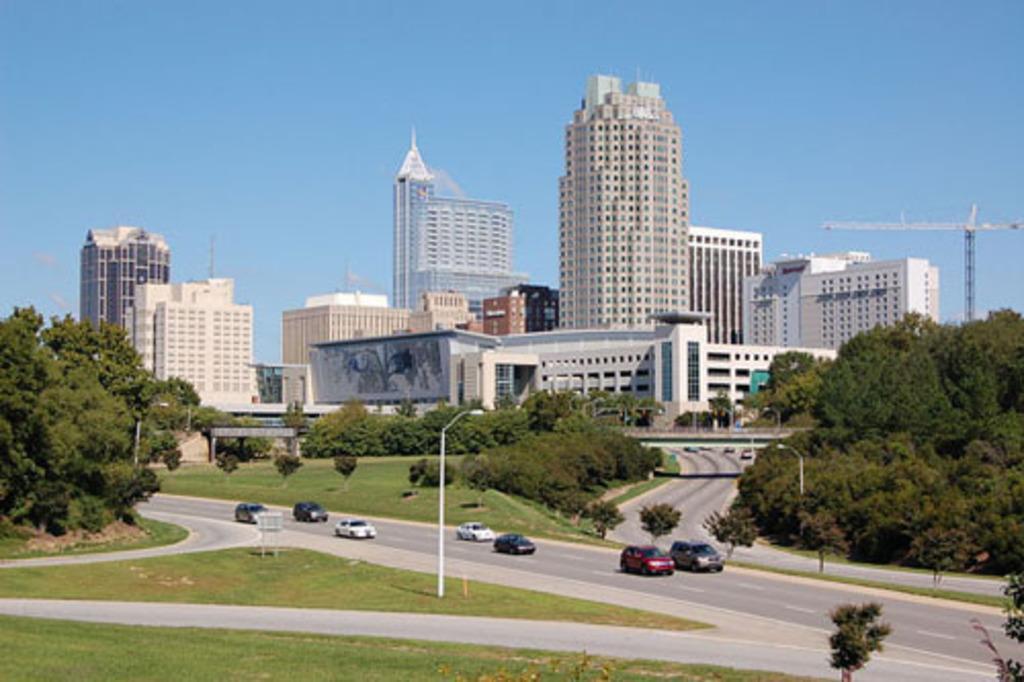Can you describe this image briefly? In this picture we can see some buildings here, there are some cars traveling on the road, we can see a pole and light here, at the bottom there is grass, we can see trees here, on the right side there is a tower, we can see the sky at the top of the picture. 